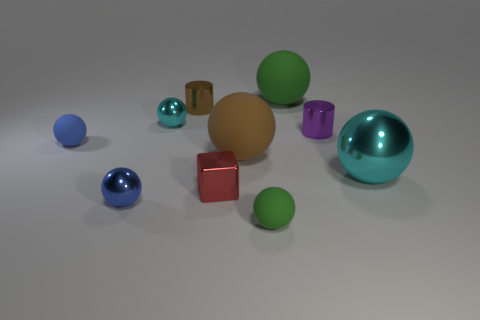Subtract all brown balls. How many balls are left? 6 Subtract 7 spheres. How many spheres are left? 0 Subtract all brown balls. How many balls are left? 6 Subtract all balls. How many objects are left? 3 Subtract all red cylinders. How many cyan spheres are left? 2 Subtract all big green objects. Subtract all big things. How many objects are left? 6 Add 3 small blue rubber things. How many small blue rubber things are left? 4 Add 10 purple metal balls. How many purple metal balls exist? 10 Subtract 0 yellow cylinders. How many objects are left? 10 Subtract all gray spheres. Subtract all purple cylinders. How many spheres are left? 7 